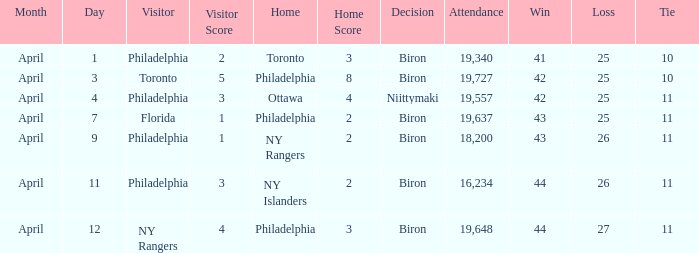What was the flyers' record when the visitors were florida? 43–25–11. 